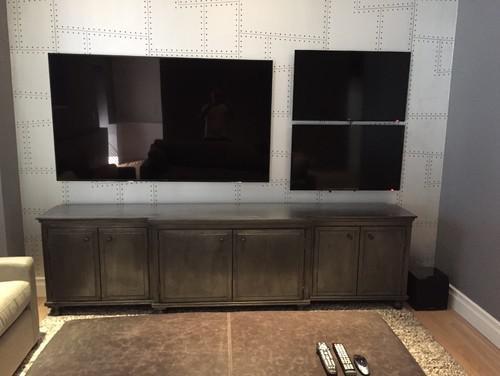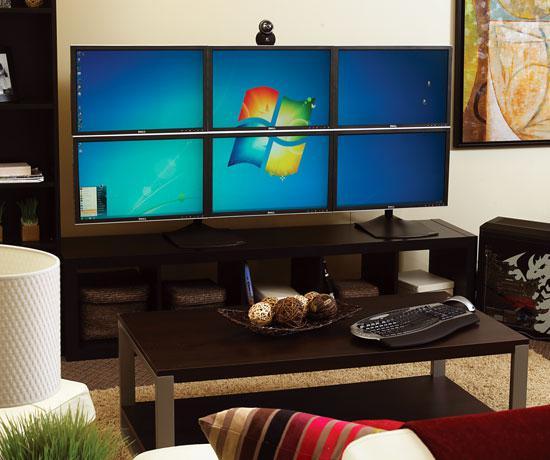The first image is the image on the left, the second image is the image on the right. Analyze the images presented: Is the assertion "Here we have more than four monitors/televisions." valid? Answer yes or no. Yes. 